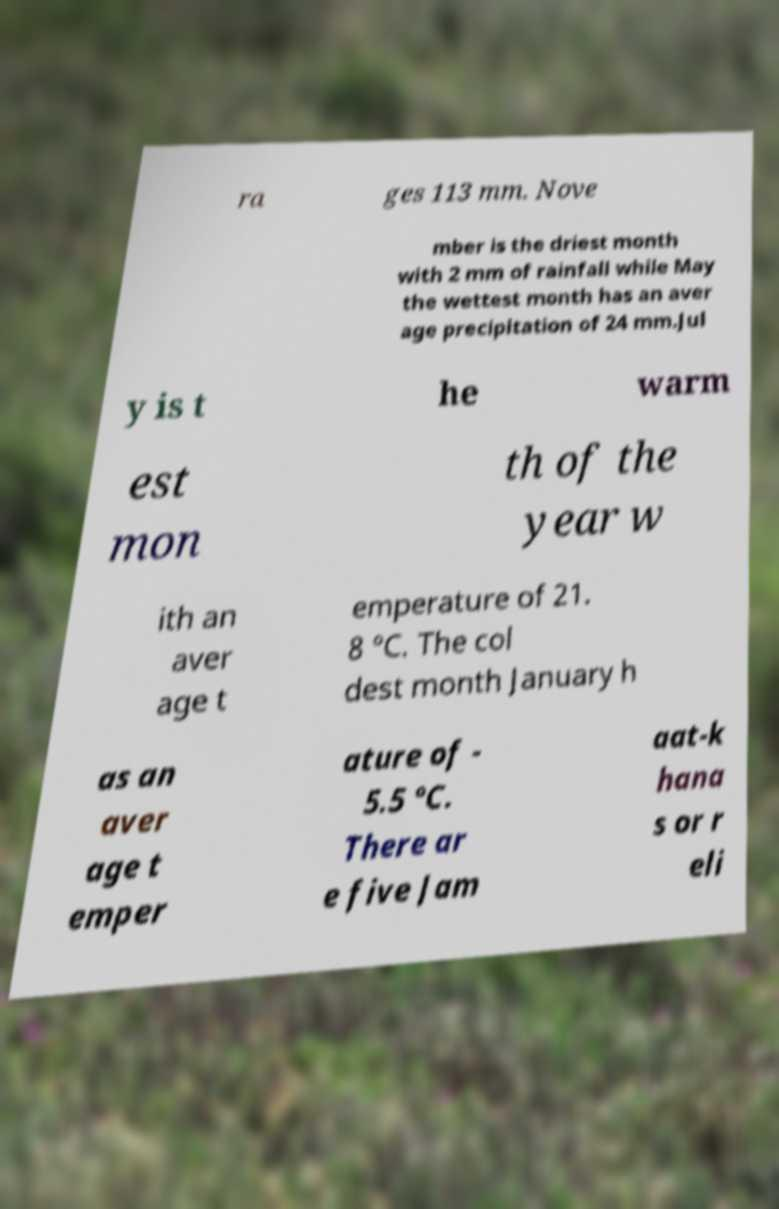Please identify and transcribe the text found in this image. ra ges 113 mm. Nove mber is the driest month with 2 mm of rainfall while May the wettest month has an aver age precipitation of 24 mm.Jul y is t he warm est mon th of the year w ith an aver age t emperature of 21. 8 °C. The col dest month January h as an aver age t emper ature of - 5.5 °C. There ar e five Jam aat-k hana s or r eli 